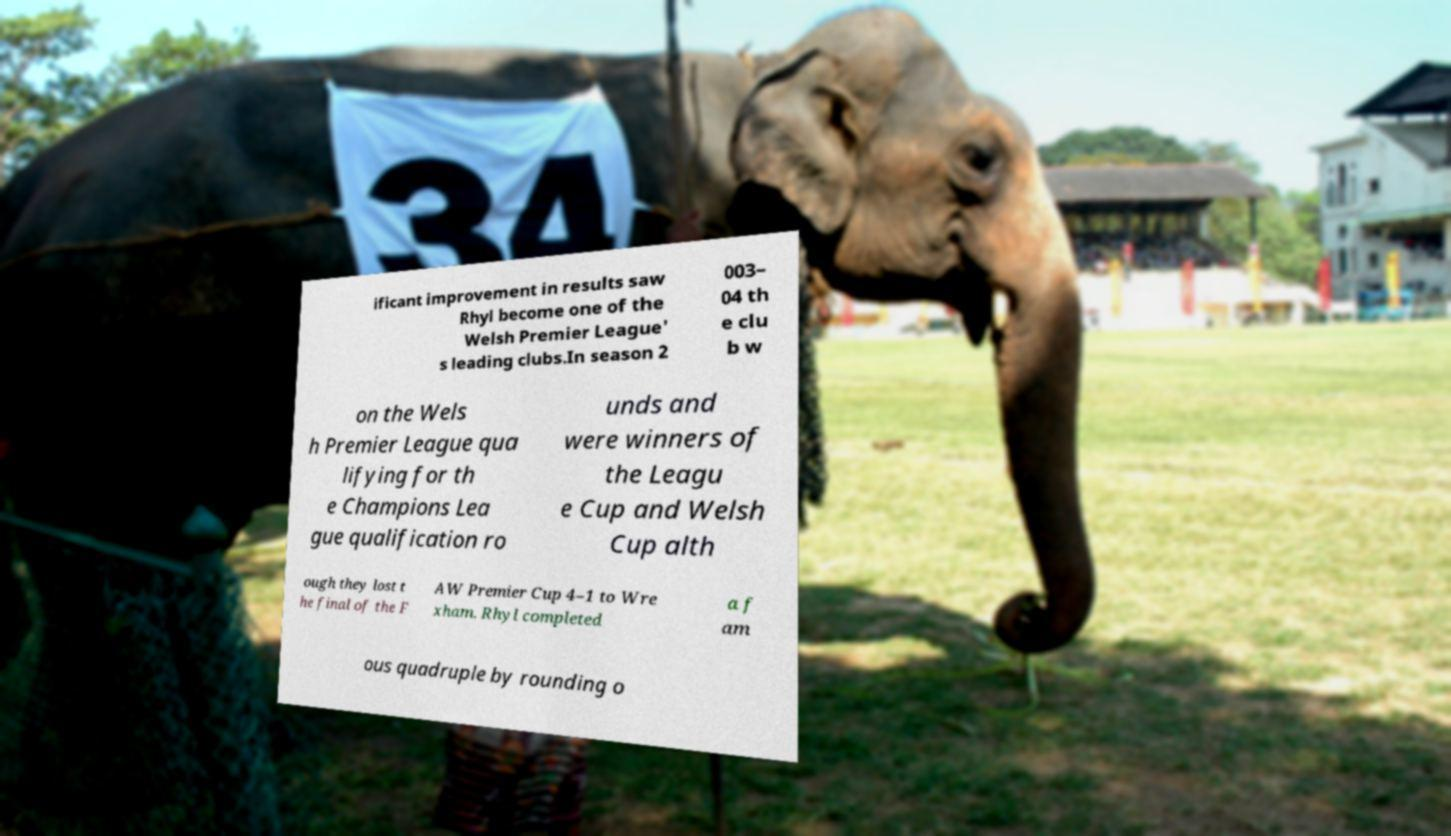Could you assist in decoding the text presented in this image and type it out clearly? ificant improvement in results saw Rhyl become one of the Welsh Premier League' s leading clubs.In season 2 003– 04 th e clu b w on the Wels h Premier League qua lifying for th e Champions Lea gue qualification ro unds and were winners of the Leagu e Cup and Welsh Cup alth ough they lost t he final of the F AW Premier Cup 4–1 to Wre xham. Rhyl completed a f am ous quadruple by rounding o 